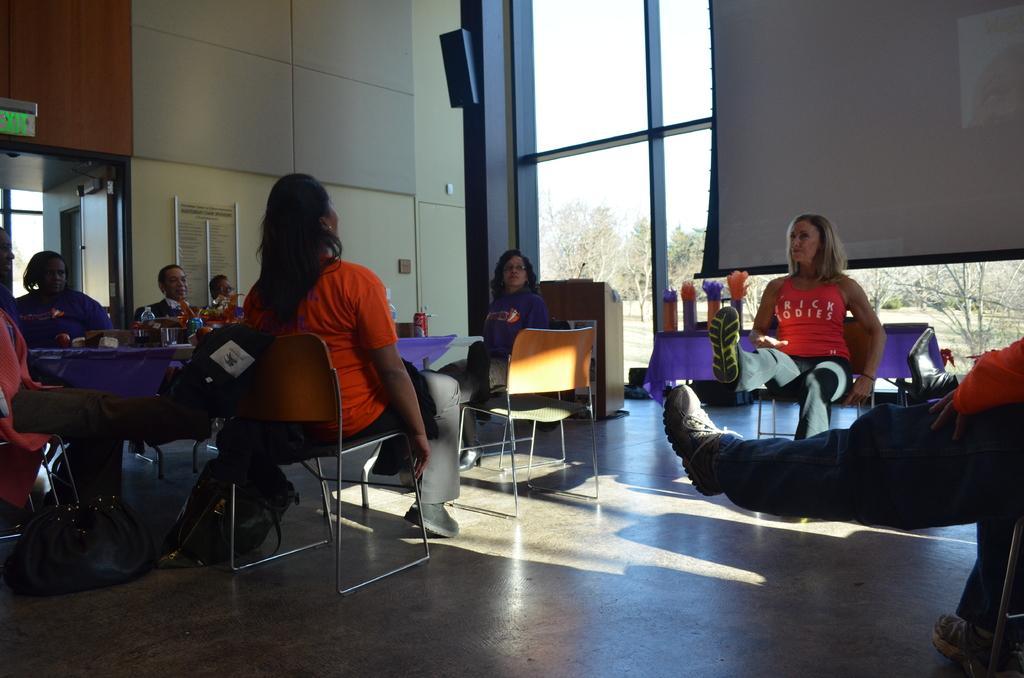Can you describe this image briefly? In this picture we can see a group of people sitting on chairs and in front of them there is table and on table we can see bottles, vase with flowers and in background we can see wall, window, screen, trees. 